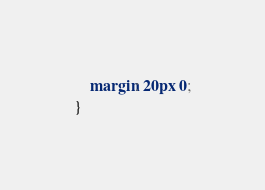Convert code to text. <code><loc_0><loc_0><loc_500><loc_500><_CSS_>    margin: 20px 0;
}
</code> 